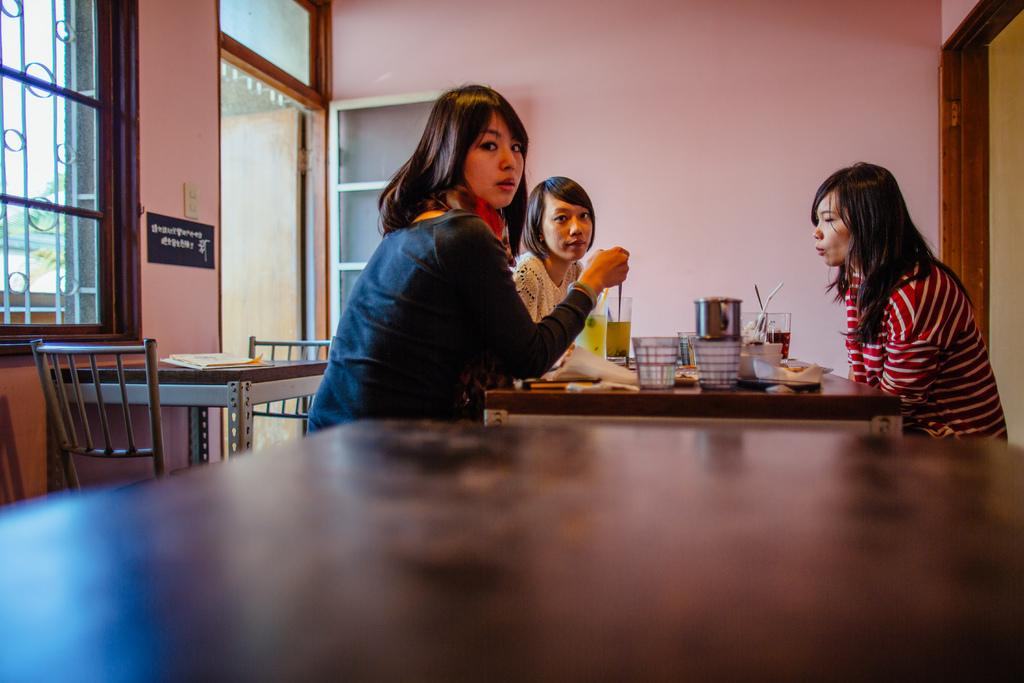Who is present in the image? There are women in the image. What are the women doing in the image? The women are sitting on chairs in the image. What objects can be seen on a table in the image? There are glasses on a table in the image. What type of flower is growing on the chair in the image? There is no flower present on the chair in the image. 